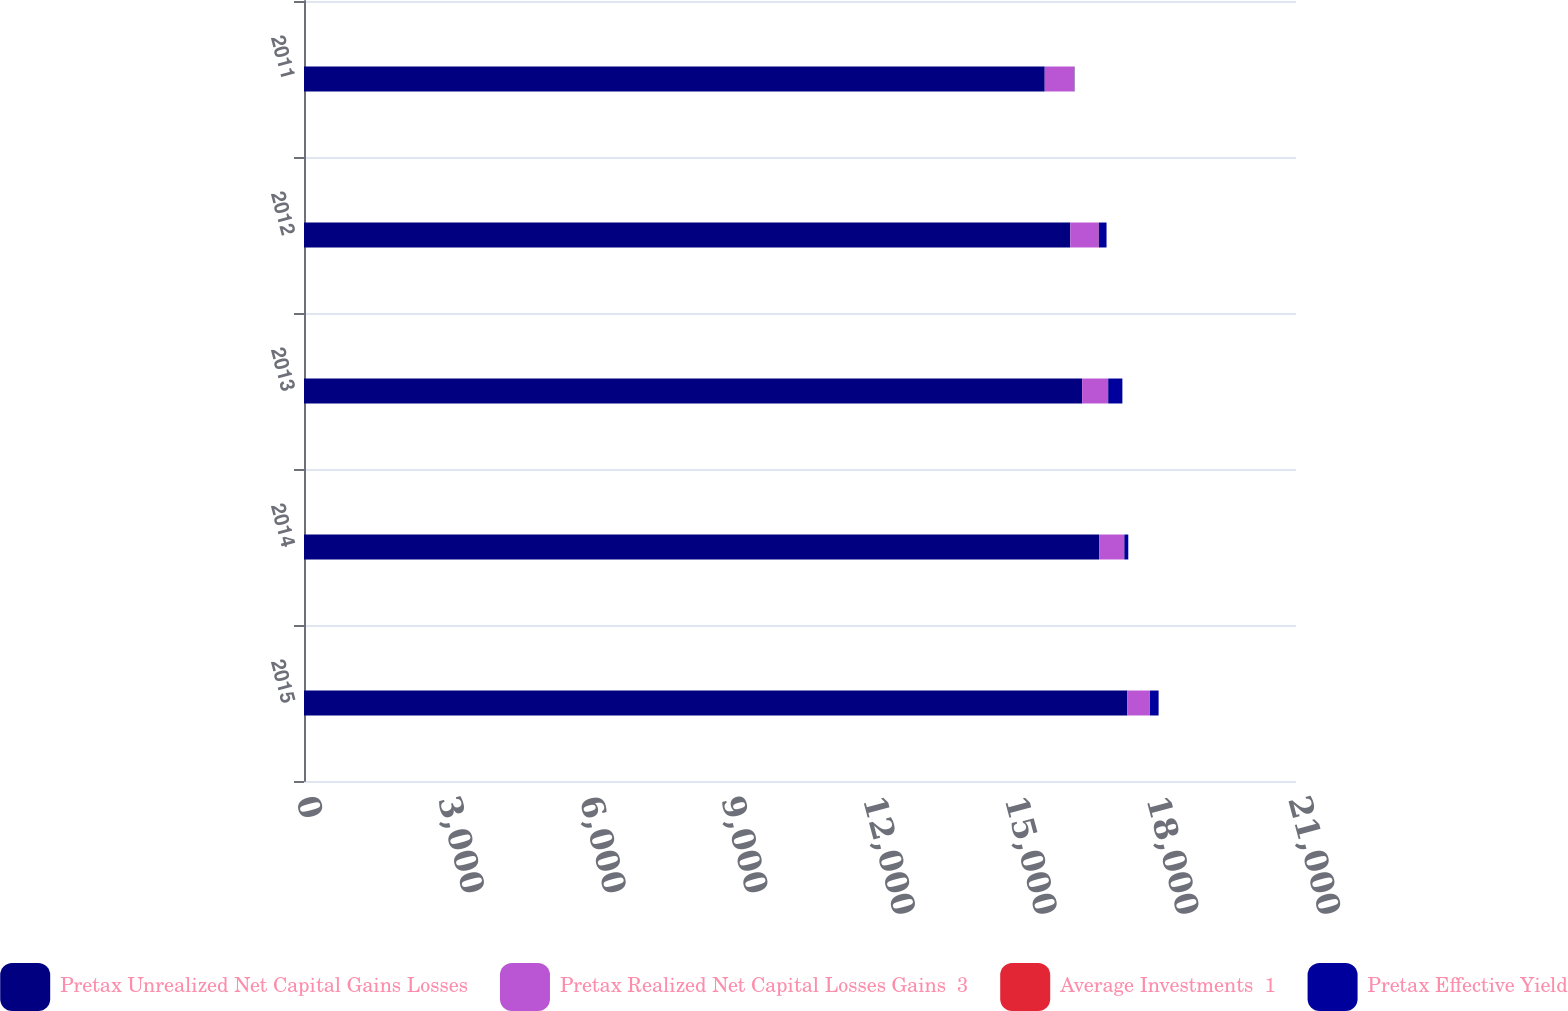<chart> <loc_0><loc_0><loc_500><loc_500><stacked_bar_chart><ecel><fcel>2015<fcel>2014<fcel>2013<fcel>2012<fcel>2011<nl><fcel>Pretax Unrealized Net Capital Gains Losses<fcel>17430.8<fcel>16831.9<fcel>16472.5<fcel>16220.9<fcel>15680.9<nl><fcel>Pretax Realized Net Capital Losses Gains  3<fcel>473.8<fcel>530.6<fcel>548.5<fcel>600.2<fcel>620<nl><fcel>Average Investments  1<fcel>2.72<fcel>3.15<fcel>3.33<fcel>3.7<fcel>3.95<nl><fcel>Pretax Effective Yield<fcel>184.1<fcel>84<fcel>300.2<fcel>164.4<fcel>6.9<nl></chart> 